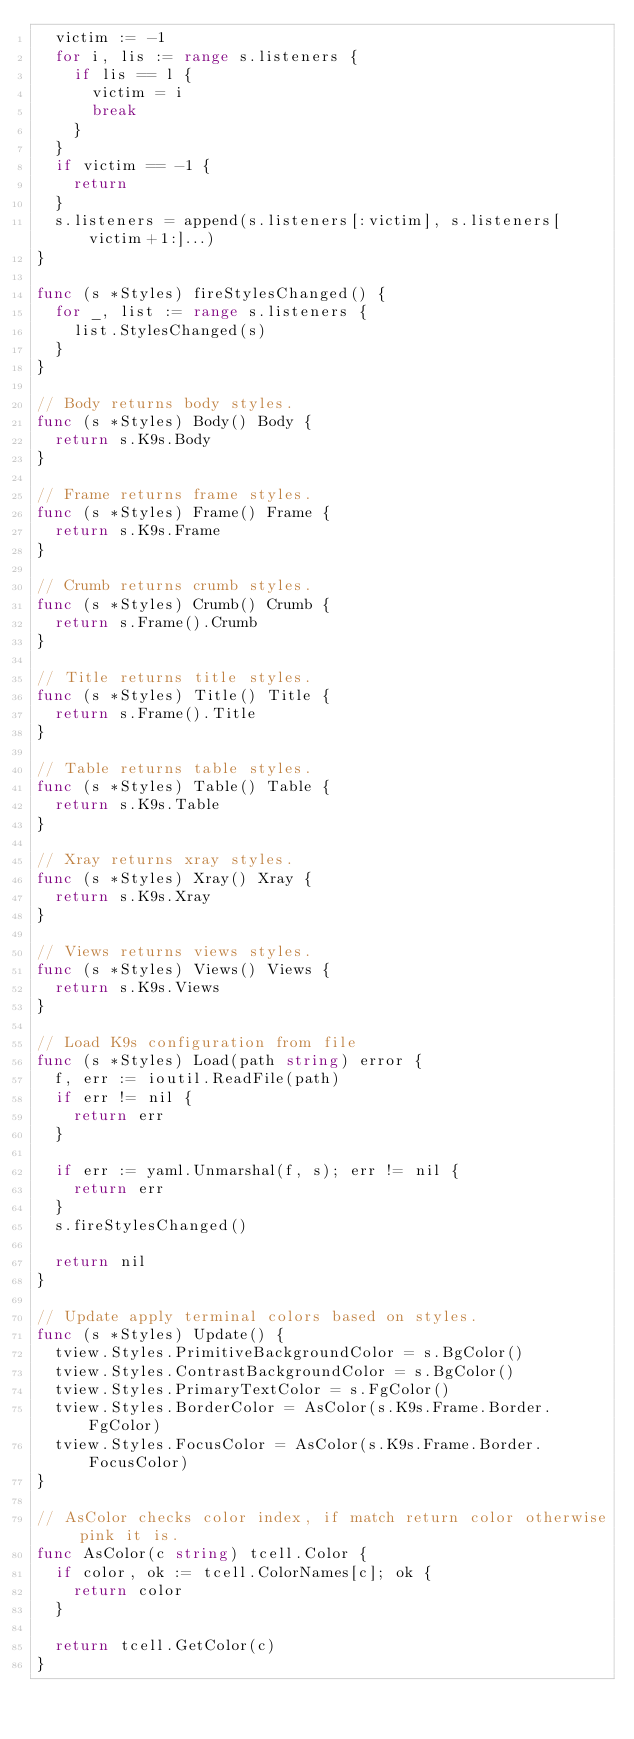Convert code to text. <code><loc_0><loc_0><loc_500><loc_500><_Go_>	victim := -1
	for i, lis := range s.listeners {
		if lis == l {
			victim = i
			break
		}
	}
	if victim == -1 {
		return
	}
	s.listeners = append(s.listeners[:victim], s.listeners[victim+1:]...)
}

func (s *Styles) fireStylesChanged() {
	for _, list := range s.listeners {
		list.StylesChanged(s)
	}
}

// Body returns body styles.
func (s *Styles) Body() Body {
	return s.K9s.Body
}

// Frame returns frame styles.
func (s *Styles) Frame() Frame {
	return s.K9s.Frame
}

// Crumb returns crumb styles.
func (s *Styles) Crumb() Crumb {
	return s.Frame().Crumb
}

// Title returns title styles.
func (s *Styles) Title() Title {
	return s.Frame().Title
}

// Table returns table styles.
func (s *Styles) Table() Table {
	return s.K9s.Table
}

// Xray returns xray styles.
func (s *Styles) Xray() Xray {
	return s.K9s.Xray
}

// Views returns views styles.
func (s *Styles) Views() Views {
	return s.K9s.Views
}

// Load K9s configuration from file
func (s *Styles) Load(path string) error {
	f, err := ioutil.ReadFile(path)
	if err != nil {
		return err
	}

	if err := yaml.Unmarshal(f, s); err != nil {
		return err
	}
	s.fireStylesChanged()

	return nil
}

// Update apply terminal colors based on styles.
func (s *Styles) Update() {
	tview.Styles.PrimitiveBackgroundColor = s.BgColor()
	tview.Styles.ContrastBackgroundColor = s.BgColor()
	tview.Styles.PrimaryTextColor = s.FgColor()
	tview.Styles.BorderColor = AsColor(s.K9s.Frame.Border.FgColor)
	tview.Styles.FocusColor = AsColor(s.K9s.Frame.Border.FocusColor)
}

// AsColor checks color index, if match return color otherwise pink it is.
func AsColor(c string) tcell.Color {
	if color, ok := tcell.ColorNames[c]; ok {
		return color
	}

	return tcell.GetColor(c)
}
</code> 